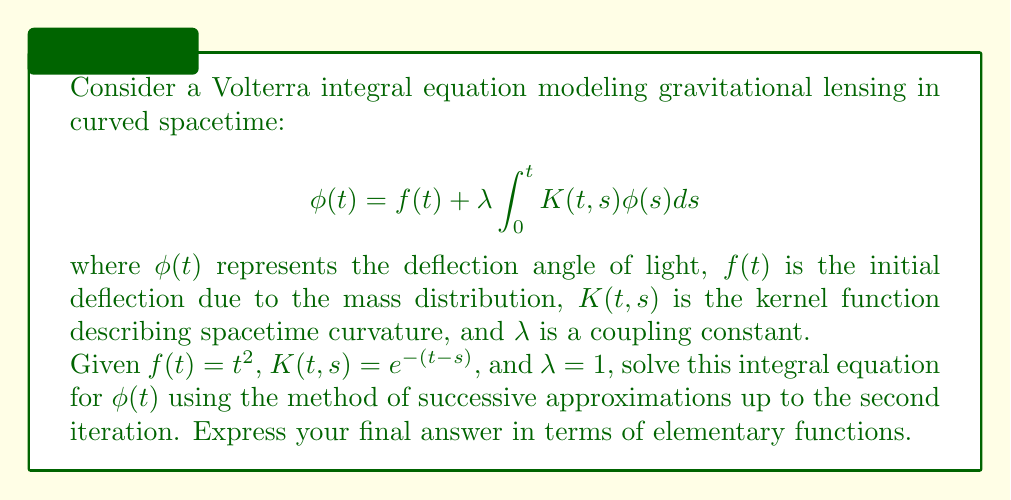Show me your answer to this math problem. To solve this Volterra integral equation using the method of successive approximations, we follow these steps:

1) Start with the initial approximation $\phi_0(t) = f(t) = t^2$

2) Use the recurrence relation:
   $$\phi_{n+1}(t) = f(t) + \lambda \int_0^t K(t,s) \phi_n(s) ds$$

3) Calculate $\phi_1(t)$:
   $$\begin{aligned}
   \phi_1(t) &= t^2 + \int_0^t e^{-(t-s)} s^2 ds \\
   &= t^2 + e^{-t} \int_0^t e^s s^2 ds
   \end{aligned}$$

   To evaluate the integral, use integration by parts twice:
   $$\begin{aligned}
   \int e^s s^2 ds &= e^s s^2 - 2e^s s + 2e^s + C
   \end{aligned}$$

   Applying the limits:
   $$\begin{aligned}
   \phi_1(t) &= t^2 + e^{-t} [(e^t t^2 - 2e^t t + 2e^t) - (0 - 0 + 2)] \\
   &= t^2 + (t^2 - 2t + 2) - 2e^{-t}
   \end{aligned}$$

4) Calculate $\phi_2(t)$:
   $$\begin{aligned}
   \phi_2(t) &= t^2 + \int_0^t e^{-(t-s)} [s^2 + (s^2 - 2s + 2) - 2e^{-s}] ds \\
   &= t^2 + e^{-t} \int_0^t e^s [2s^2 - 2s + 2] ds - 2 \int_0^t e^{-(t-s)} e^{-s} ds
   \end{aligned}$$

   For the first integral, use the result from step 3 and apply it to $2s^2 - 2s + 2$:
   $$\begin{aligned}
   \int_0^t e^s [2s^2 - 2s + 2] ds &= [2e^s s^2 - 4e^s s + 6e^s]_0^t \\
   &= 2e^t t^2 - 4e^t t + 6e^t - 6
   \end{aligned}$$

   For the second integral:
   $$\begin{aligned}
   2 \int_0^t e^{-(t-s)} e^{-s} ds &= 2e^{-t} \int_0^t ds = 2te^{-t}
   \end{aligned}$$

   Combining these results:
   $$\begin{aligned}
   \phi_2(t) &= t^2 + (2t^2 - 4t + 6 - 6e^{-t}) - 2te^{-t} \\
   &= 3t^2 - 4t + 6 - 6e^{-t} - 2te^{-t}
   \end{aligned}$$

Thus, the second iteration approximation for $\phi(t)$ is $\phi_2(t)$.
Answer: $\phi(t) \approx 3t^2 - 4t + 6 - e^{-t}(6 + 2t)$ 